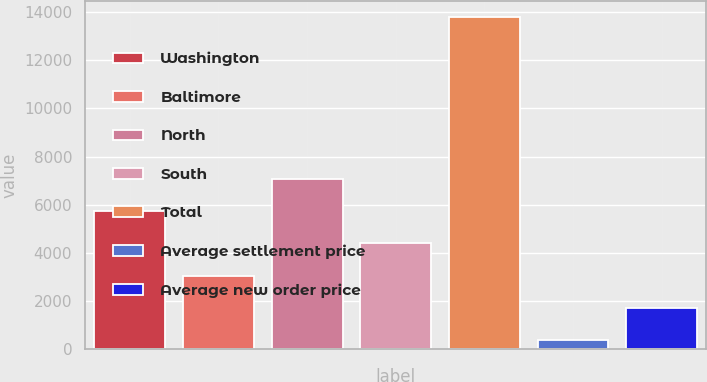Convert chart. <chart><loc_0><loc_0><loc_500><loc_500><bar_chart><fcel>Washington<fcel>Baltimore<fcel>North<fcel>South<fcel>Total<fcel>Average settlement price<fcel>Average new order price<nl><fcel>5739.74<fcel>3057.32<fcel>7080.95<fcel>4398.53<fcel>13787<fcel>374.9<fcel>1716.11<nl></chart> 